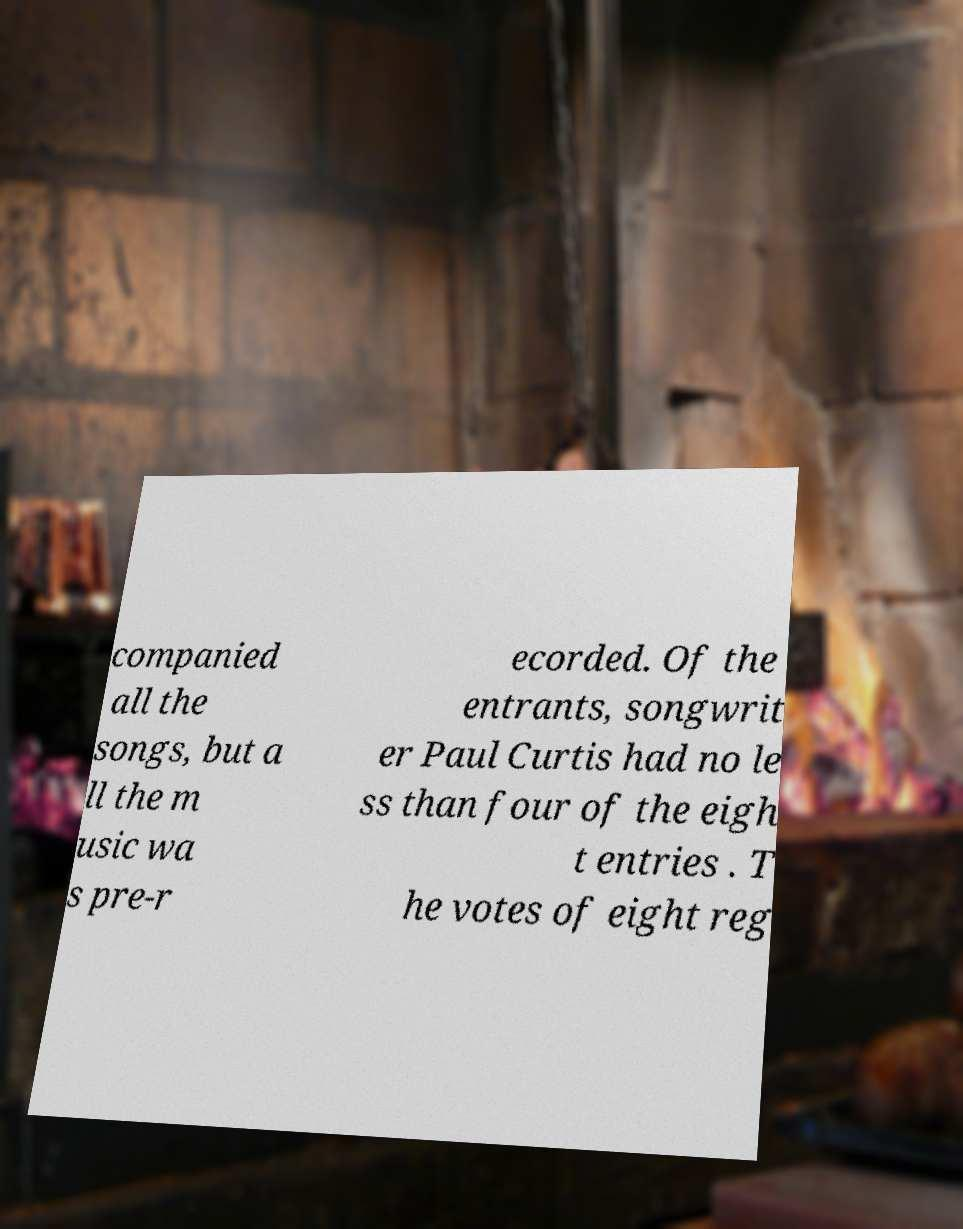There's text embedded in this image that I need extracted. Can you transcribe it verbatim? companied all the songs, but a ll the m usic wa s pre-r ecorded. Of the entrants, songwrit er Paul Curtis had no le ss than four of the eigh t entries . T he votes of eight reg 